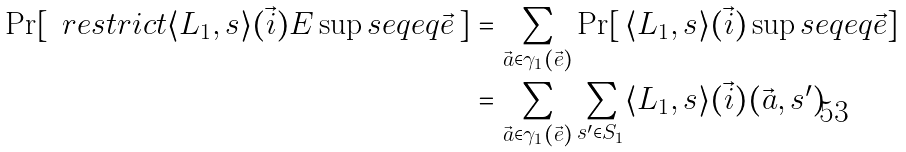<formula> <loc_0><loc_0><loc_500><loc_500>\Pr [ \, \ r e s t r i c t { \langle L _ { 1 } , s \rangle ( \vec { i } ) } { E } \sup s e q e q \vec { e } \, ] & = \sum _ { \vec { a } \in \gamma _ { 1 } ( \vec { e } ) } \Pr [ \, \langle L _ { 1 } , s \rangle ( \vec { i } ) \sup s e q e q \vec { e } ] \\ & = \sum _ { \vec { a } \in \gamma _ { 1 } ( \vec { e } ) } \sum _ { s ^ { \prime } \in S _ { 1 } } \langle L _ { 1 } , s \rangle ( \vec { i } ) ( \vec { a } , s ^ { \prime } )</formula> 